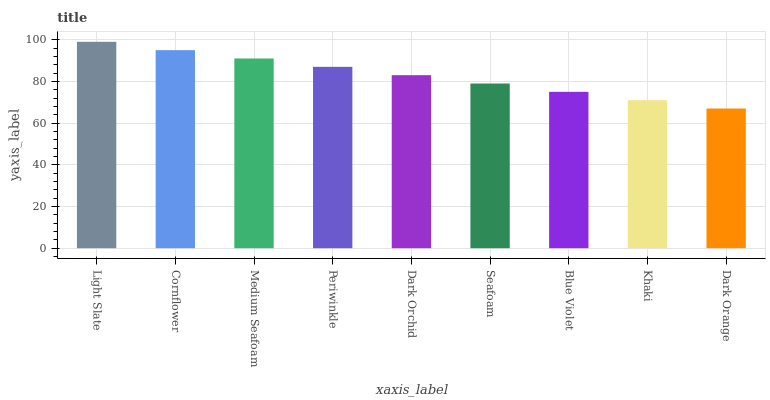Is Dark Orange the minimum?
Answer yes or no. Yes. Is Light Slate the maximum?
Answer yes or no. Yes. Is Cornflower the minimum?
Answer yes or no. No. Is Cornflower the maximum?
Answer yes or no. No. Is Light Slate greater than Cornflower?
Answer yes or no. Yes. Is Cornflower less than Light Slate?
Answer yes or no. Yes. Is Cornflower greater than Light Slate?
Answer yes or no. No. Is Light Slate less than Cornflower?
Answer yes or no. No. Is Dark Orchid the high median?
Answer yes or no. Yes. Is Dark Orchid the low median?
Answer yes or no. Yes. Is Medium Seafoam the high median?
Answer yes or no. No. Is Medium Seafoam the low median?
Answer yes or no. No. 